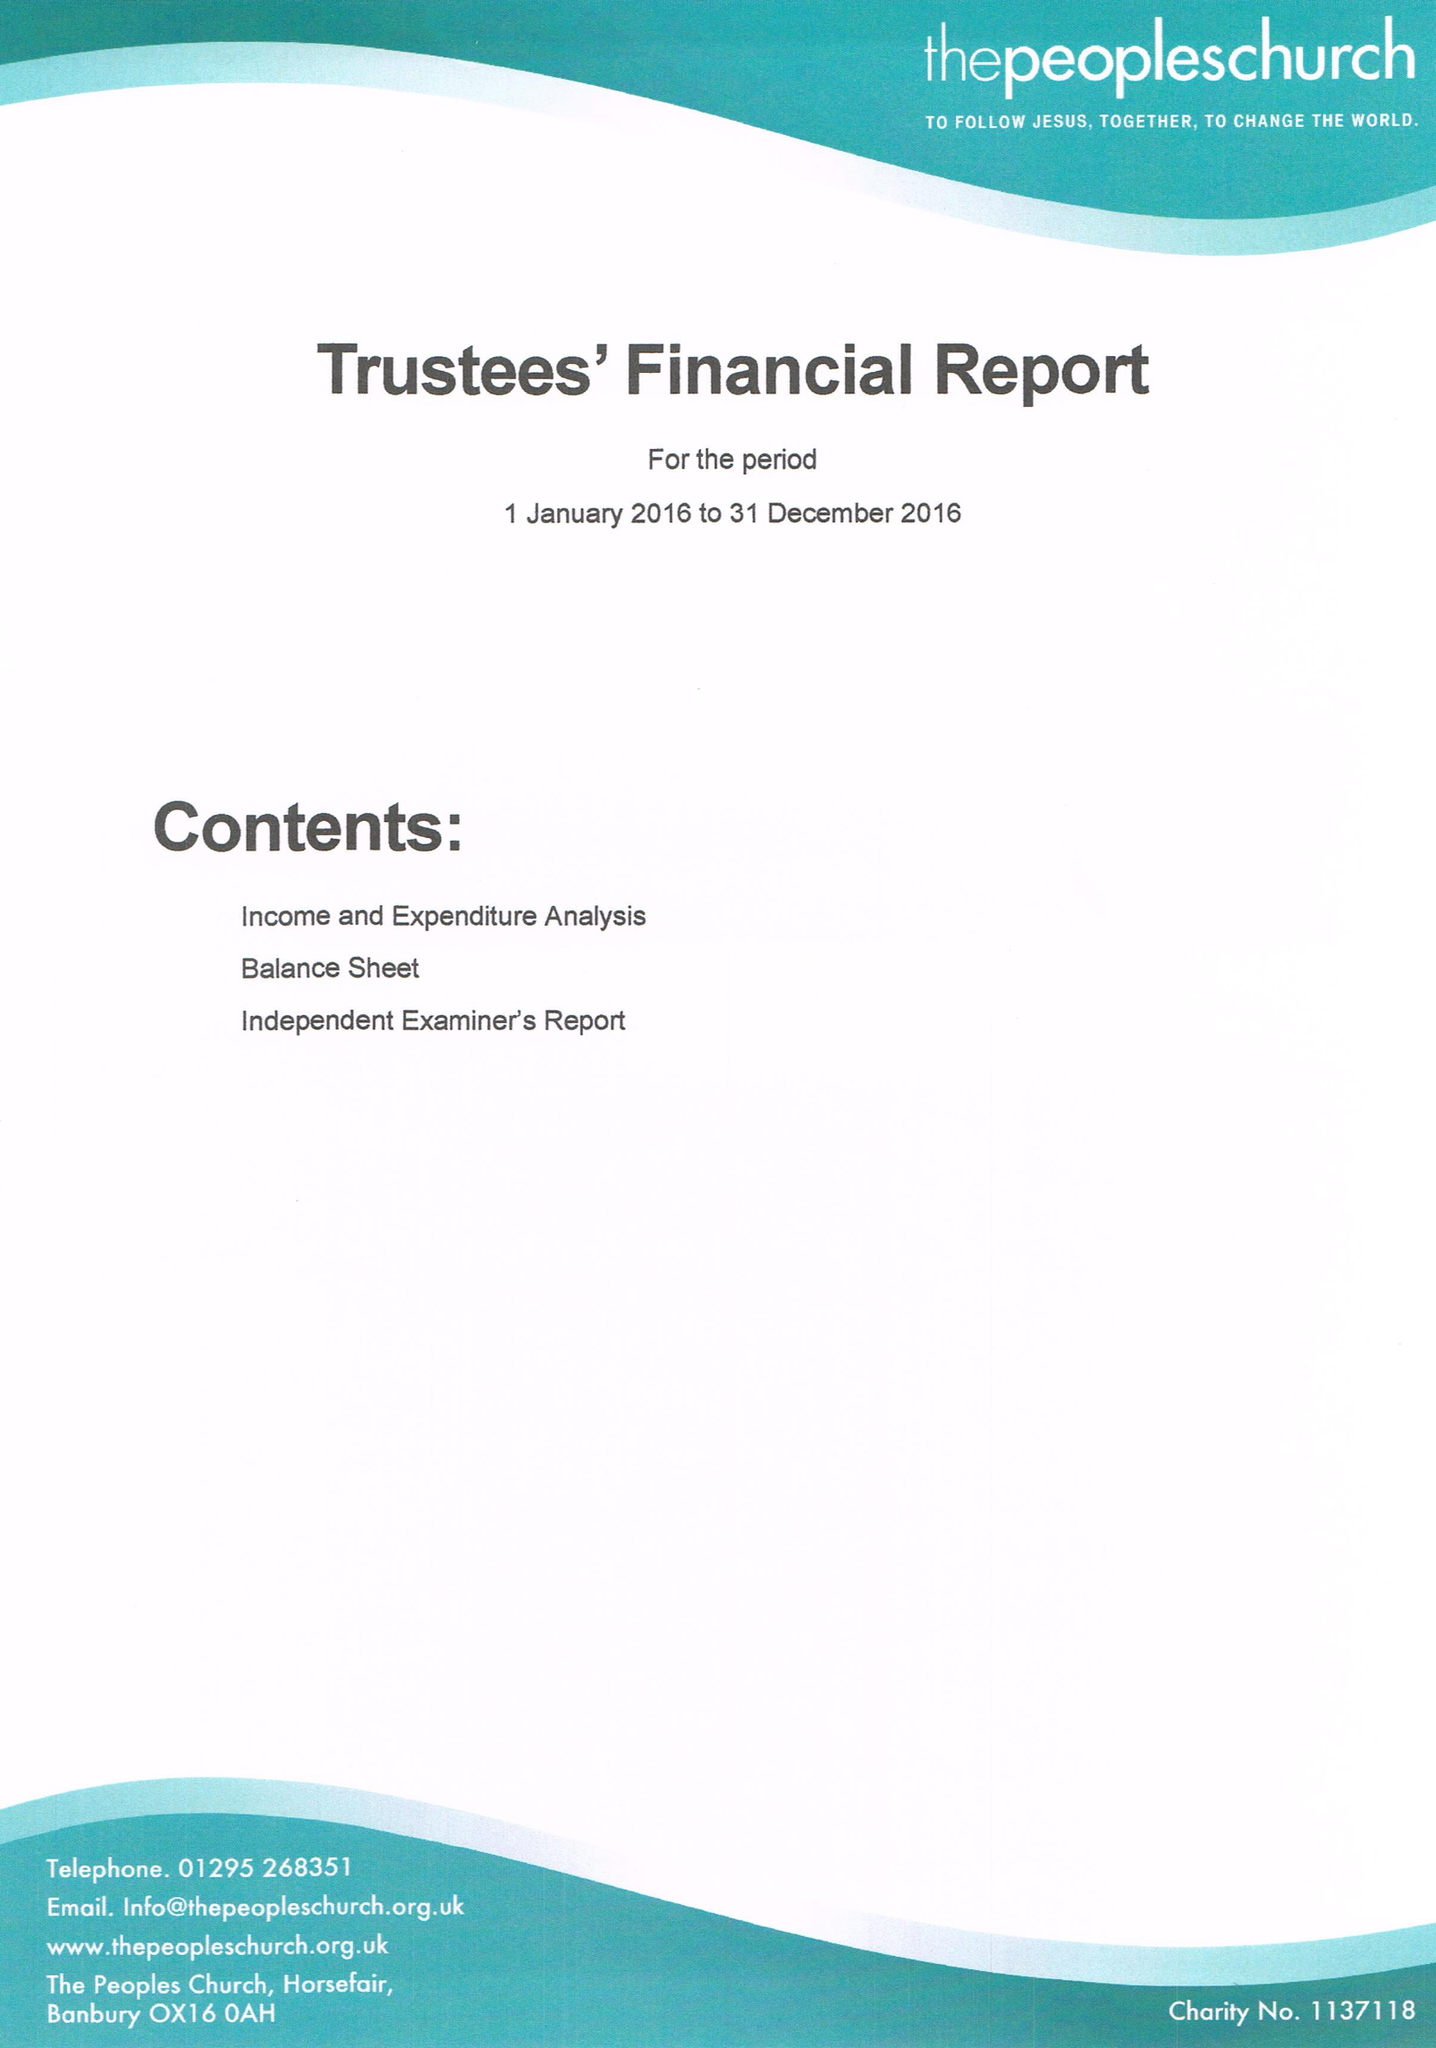What is the value for the charity_name?
Answer the question using a single word or phrase. The Peoples Church (Banbury) 